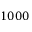Convert formula to latex. <formula><loc_0><loc_0><loc_500><loc_500>1 0 0 0</formula> 